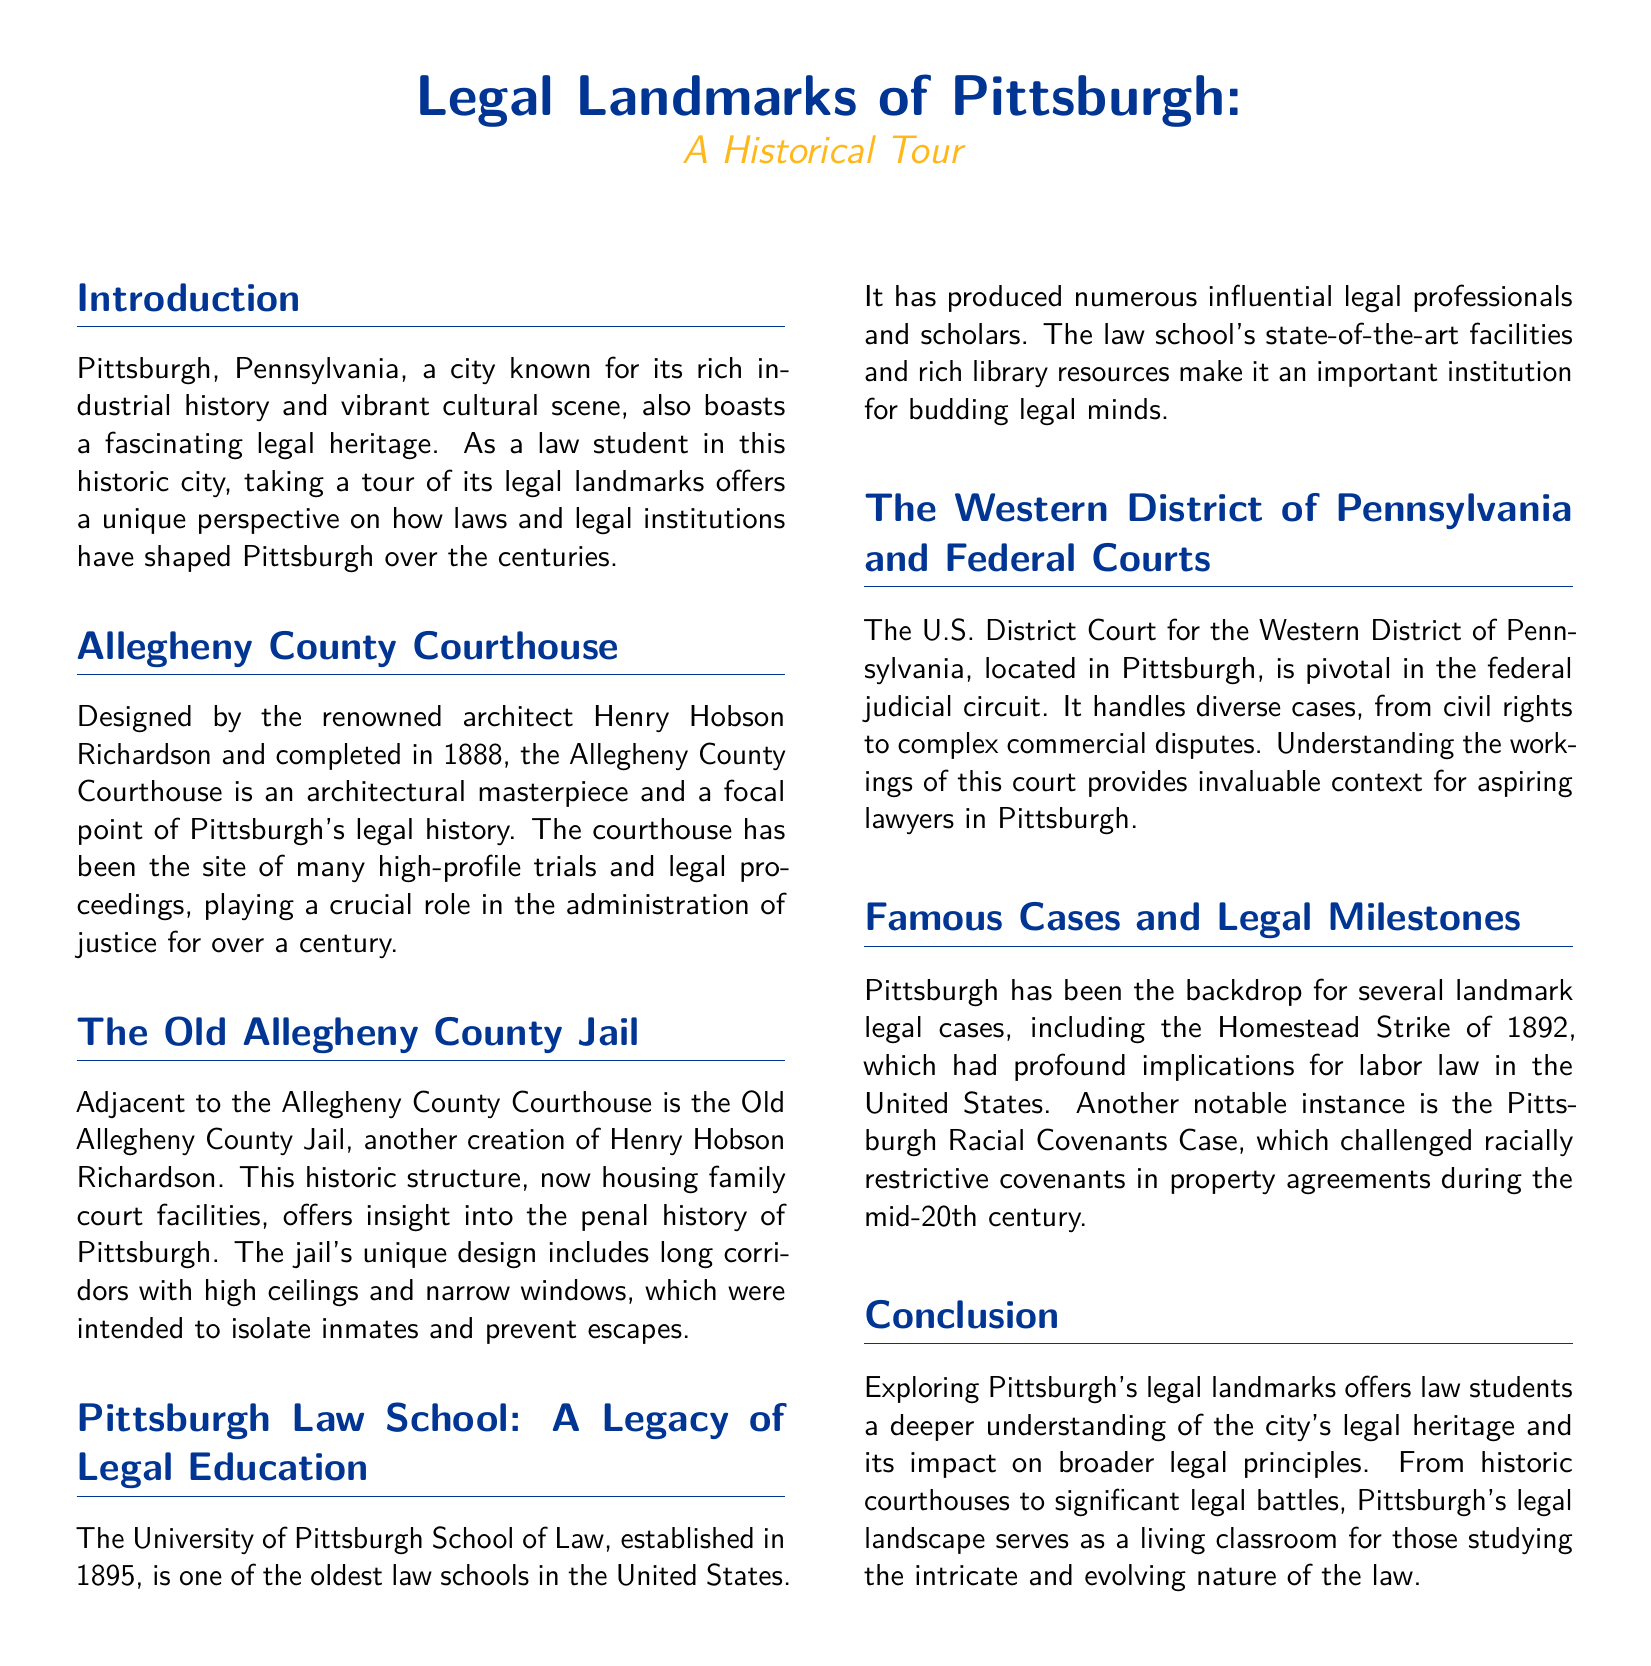What year was the Allegheny County Courthouse completed? The document states that the Allegheny County Courthouse was completed in 1888.
Answer: 1888 Who designed the Old Allegheny County Jail? The document indicates that the Old Allegheny County Jail was designed by Henry Hobson Richardson.
Answer: Henry Hobson Richardson What year was the University of Pittsburgh School of Law established? According to the document, the University of Pittsburgh School of Law was established in 1895.
Answer: 1895 What type of cases does the U.S. District Court for the Western District of Pennsylvania handle? The document mentions that this court handles diverse cases, including civil rights and complex commercial disputes.
Answer: Civil rights and complex commercial disputes Which legal event had implications for labor law in the United States? The document identifies the Homestead Strike of 1892 as having profound implications for labor law.
Answer: Homestead Strike of 1892 What architectural style is the Allegheny County Courthouse associated with? The document describes the Allegheny County Courthouse as an architectural masterpiece, linking it to the style of Henry Hobson Richardson.
Answer: Architectural masterpiece How does exploring legal landmarks benefit law students? The document concludes that exploring these landmarks offers law students a deeper understanding of the city's legal heritage.
Answer: Deeper understanding What does the document primarily focus on? The document primarily focuses on legal landmarks in Pittsburgh and their historical significance.
Answer: Legal landmarks in Pittsburgh Where is the U.S. District Court for the Western District of Pennsylvania located? The document states that this court is located in Pittsburgh.
Answer: Pittsburgh 